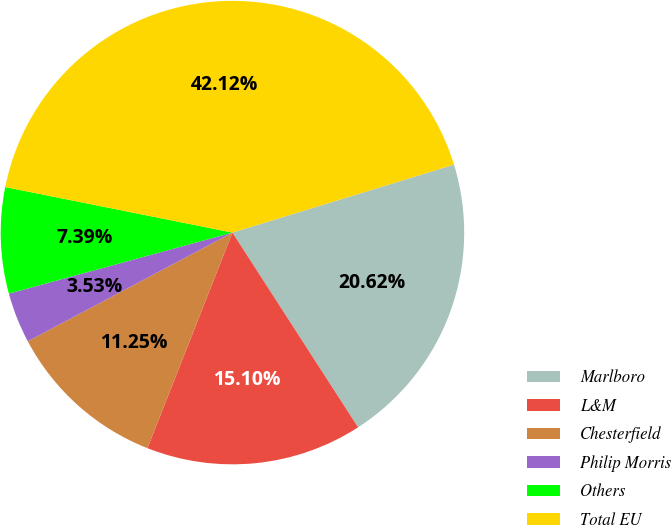<chart> <loc_0><loc_0><loc_500><loc_500><pie_chart><fcel>Marlboro<fcel>L&M<fcel>Chesterfield<fcel>Philip Morris<fcel>Others<fcel>Total EU<nl><fcel>20.62%<fcel>15.1%<fcel>11.25%<fcel>3.53%<fcel>7.39%<fcel>42.12%<nl></chart> 